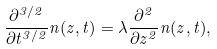Convert formula to latex. <formula><loc_0><loc_0><loc_500><loc_500>\frac { \partial ^ { 3 / 2 } } { \partial t ^ { 3 / 2 } } n ( z , t ) = \lambda \frac { \partial ^ { 2 } } { \partial z ^ { 2 } } n ( z , t ) ,</formula> 